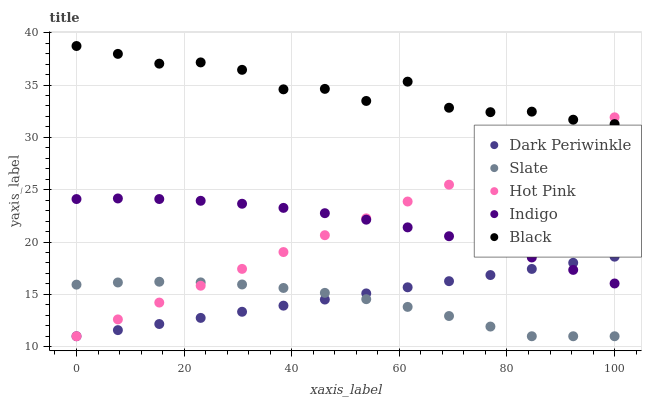Does Slate have the minimum area under the curve?
Answer yes or no. Yes. Does Black have the maximum area under the curve?
Answer yes or no. Yes. Does Hot Pink have the minimum area under the curve?
Answer yes or no. No. Does Hot Pink have the maximum area under the curve?
Answer yes or no. No. Is Dark Periwinkle the smoothest?
Answer yes or no. Yes. Is Black the roughest?
Answer yes or no. Yes. Is Slate the smoothest?
Answer yes or no. No. Is Slate the roughest?
Answer yes or no. No. Does Slate have the lowest value?
Answer yes or no. Yes. Does Indigo have the lowest value?
Answer yes or no. No. Does Black have the highest value?
Answer yes or no. Yes. Does Hot Pink have the highest value?
Answer yes or no. No. Is Dark Periwinkle less than Black?
Answer yes or no. Yes. Is Indigo greater than Slate?
Answer yes or no. Yes. Does Slate intersect Dark Periwinkle?
Answer yes or no. Yes. Is Slate less than Dark Periwinkle?
Answer yes or no. No. Is Slate greater than Dark Periwinkle?
Answer yes or no. No. Does Dark Periwinkle intersect Black?
Answer yes or no. No. 